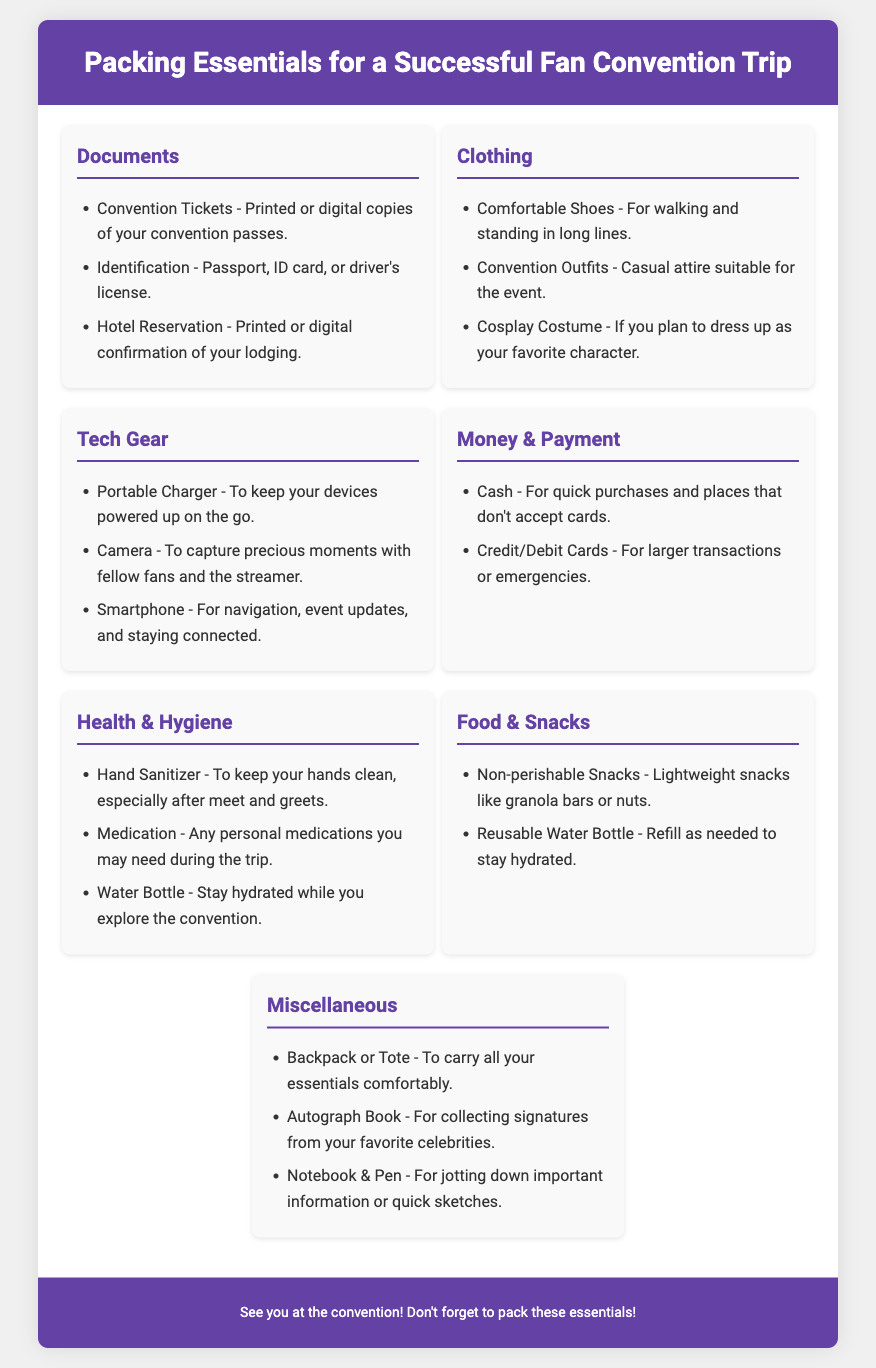What should you bring for identification? Identification is listed as one of the documents needed for the trip, which includes passport, ID card, or driver's license.
Answer: Passport, ID card, or driver's license What type of snacks are recommended? The document suggests lightweight snacks, which should be non-perishable.
Answer: Non-perishable Snacks How many categories are there in the packing essentials? There are a total of six different categories listed in the document.
Answer: Six What clothing item is essential for comfort during the convention? Comfortable shoes are specifically mentioned as essential for walking and standing in long lines.
Answer: Comfortable Shoes What type of book is suggested for autographs? An autograph book is recommended for collecting signatures from favorite celebrities.
Answer: Autograph Book What is necessary to keep your devices powered? A portable charger is included in the tech gear section for keeping devices powered up.
Answer: Portable Charger What should you use to stay hydrated? The essential items listed include both a water bottle and a reusable water bottle for hydration.
Answer: Water Bottle How should you carry all your essentials? A backpack or tote is suggested for comfortably carrying all essentials during the trip.
Answer: Backpack or Tote 